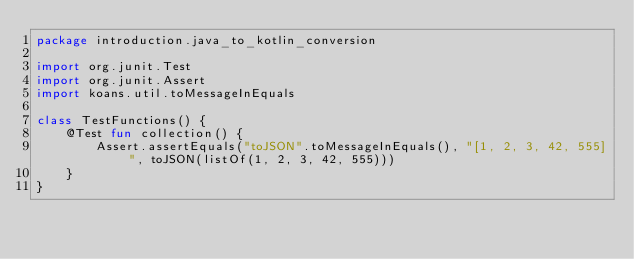<code> <loc_0><loc_0><loc_500><loc_500><_Kotlin_>package introduction.java_to_kotlin_conversion

import org.junit.Test
import org.junit.Assert
import koans.util.toMessageInEquals

class TestFunctions() {
    @Test fun collection() {
        Assert.assertEquals("toJSON".toMessageInEquals(), "[1, 2, 3, 42, 555]", toJSON(listOf(1, 2, 3, 42, 555)))
    }
}</code> 